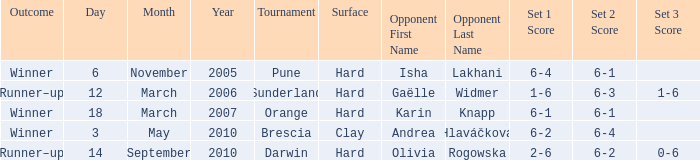The tournament at sunderland took place on which kind of surface? Hard. 